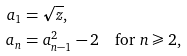Convert formula to latex. <formula><loc_0><loc_0><loc_500><loc_500>a _ { 1 } & = \sqrt { z } , \\ a _ { n } & = a _ { n - 1 } ^ { 2 } - 2 \quad \text {for $n\geqslant2$} ,</formula> 